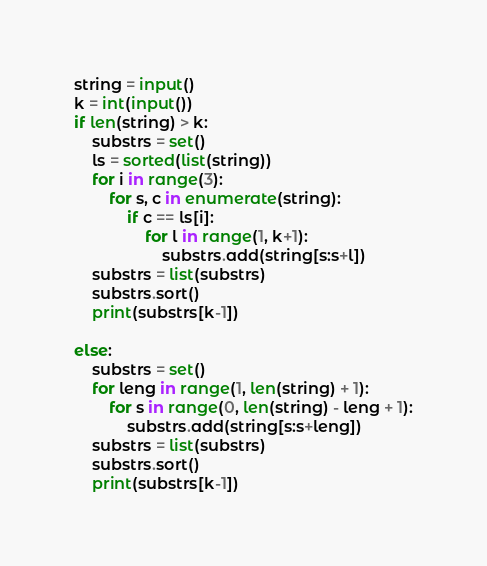Convert code to text. <code><loc_0><loc_0><loc_500><loc_500><_Python_>string = input()
k = int(input())
if len(string) > k:
    substrs = set()
    ls = sorted(list(string))
    for i in range(3):
        for s, c in enumerate(string):
            if c == ls[i]:
                for l in range(1, k+1):
                    substrs.add(string[s:s+l])
    substrs = list(substrs)
    substrs.sort()
    print(substrs[k-1])

else:
    substrs = set()
    for leng in range(1, len(string) + 1):
        for s in range(0, len(string) - leng + 1):
            substrs.add(string[s:s+leng])
    substrs = list(substrs)
    substrs.sort()
    print(substrs[k-1])
</code> 